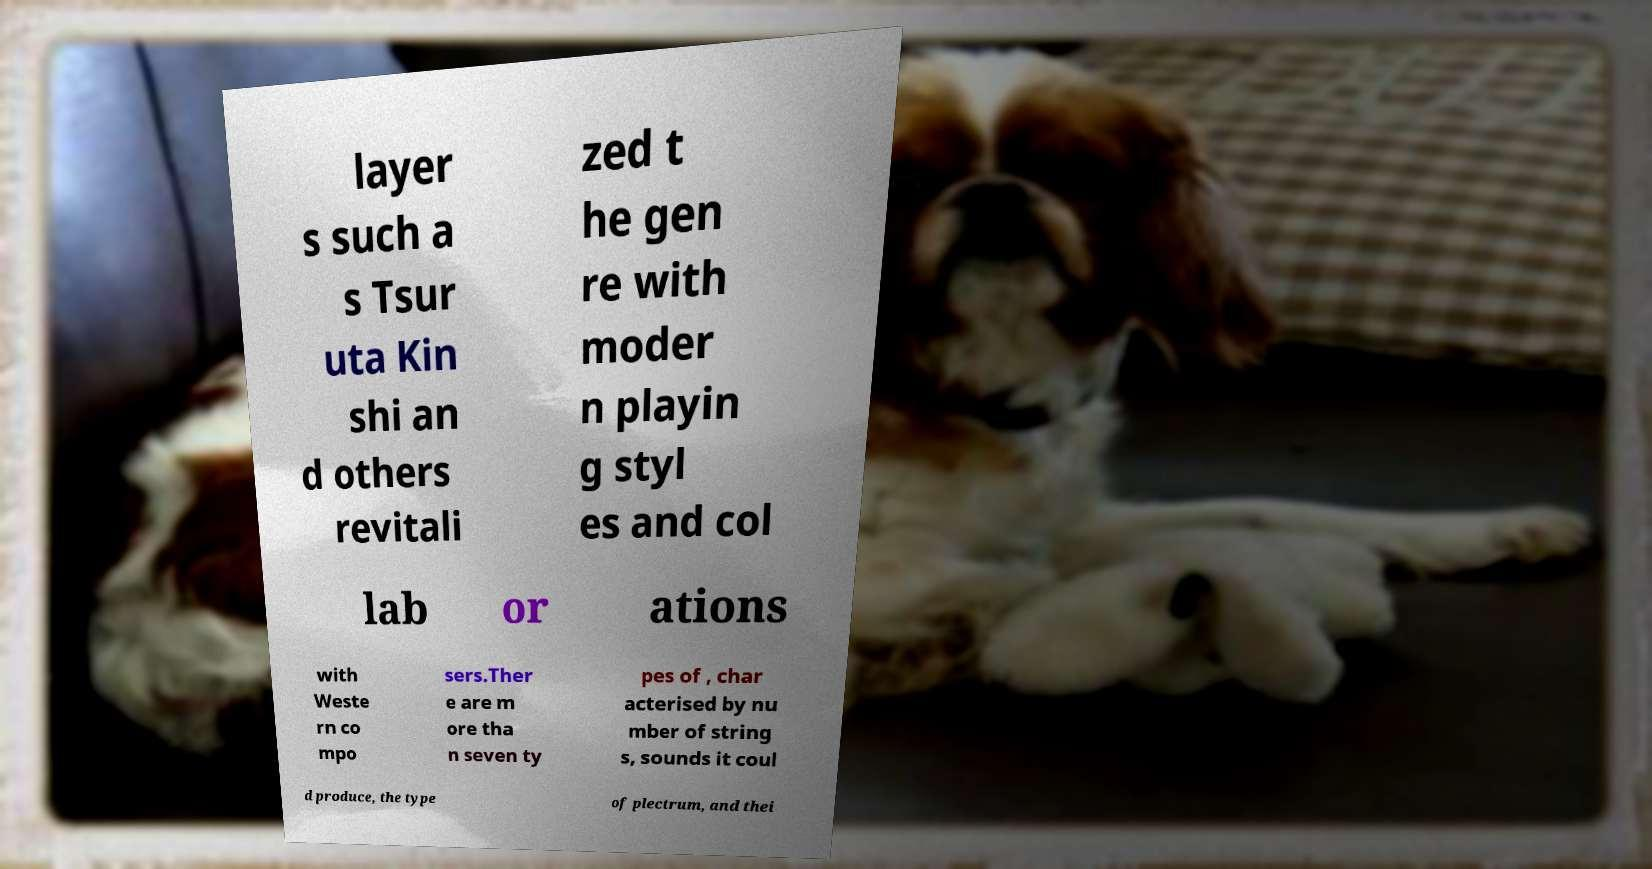For documentation purposes, I need the text within this image transcribed. Could you provide that? layer s such a s Tsur uta Kin shi an d others revitali zed t he gen re with moder n playin g styl es and col lab or ations with Weste rn co mpo sers.Ther e are m ore tha n seven ty pes of , char acterised by nu mber of string s, sounds it coul d produce, the type of plectrum, and thei 